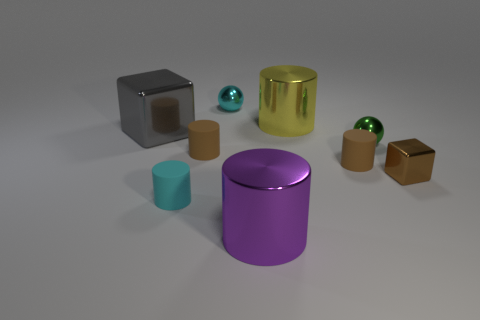Subtract all green balls. How many brown cylinders are left? 2 Subtract all purple metal cylinders. How many cylinders are left? 4 Subtract 3 cylinders. How many cylinders are left? 2 Subtract all brown cylinders. How many cylinders are left? 3 Subtract all cylinders. How many objects are left? 4 Add 5 brown rubber cylinders. How many brown rubber cylinders are left? 7 Add 7 tiny cyan cylinders. How many tiny cyan cylinders exist? 8 Subtract 0 green cylinders. How many objects are left? 9 Subtract all green cylinders. Subtract all blue spheres. How many cylinders are left? 5 Subtract all small brown objects. Subtract all yellow cylinders. How many objects are left? 5 